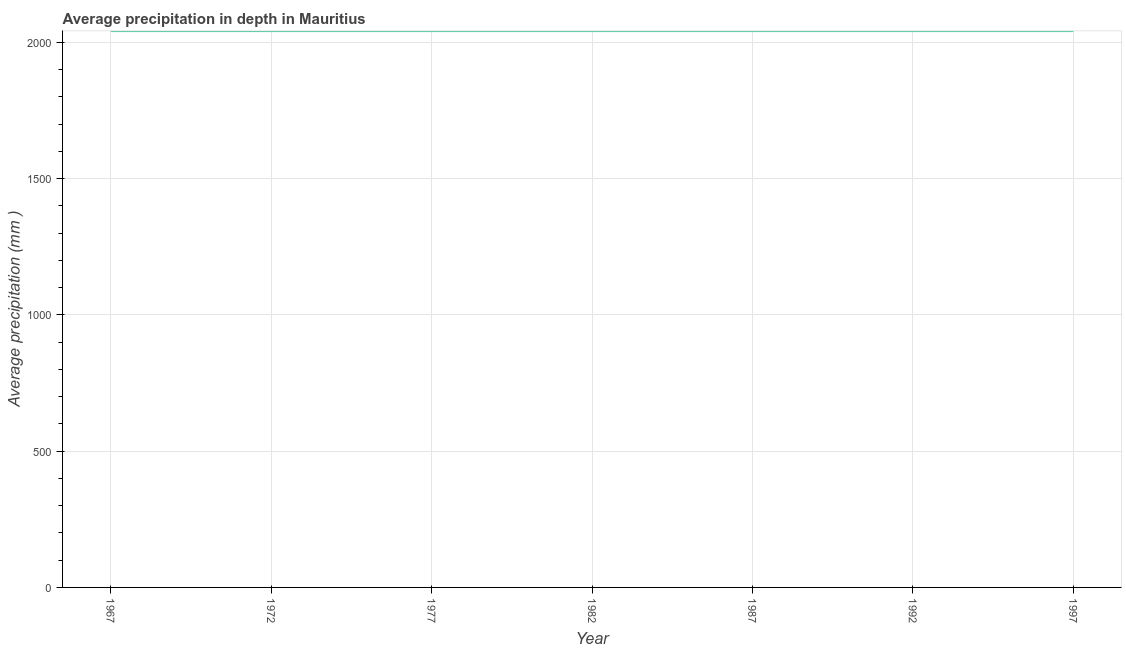What is the average precipitation in depth in 1972?
Keep it short and to the point. 2041. Across all years, what is the maximum average precipitation in depth?
Give a very brief answer. 2041. Across all years, what is the minimum average precipitation in depth?
Offer a terse response. 2041. In which year was the average precipitation in depth maximum?
Your answer should be compact. 1967. In which year was the average precipitation in depth minimum?
Give a very brief answer. 1967. What is the sum of the average precipitation in depth?
Offer a very short reply. 1.43e+04. What is the difference between the average precipitation in depth in 1977 and 1982?
Your answer should be compact. 0. What is the average average precipitation in depth per year?
Ensure brevity in your answer.  2041. What is the median average precipitation in depth?
Offer a very short reply. 2041. Do a majority of the years between 1972 and 1992 (inclusive) have average precipitation in depth greater than 700 mm?
Your answer should be very brief. Yes. Is the sum of the average precipitation in depth in 1967 and 1997 greater than the maximum average precipitation in depth across all years?
Your answer should be very brief. Yes. What is the difference between the highest and the lowest average precipitation in depth?
Provide a succinct answer. 0. Does the average precipitation in depth monotonically increase over the years?
Offer a terse response. No. How many lines are there?
Your response must be concise. 1. How many years are there in the graph?
Make the answer very short. 7. What is the difference between two consecutive major ticks on the Y-axis?
Your answer should be compact. 500. Are the values on the major ticks of Y-axis written in scientific E-notation?
Your answer should be very brief. No. What is the title of the graph?
Give a very brief answer. Average precipitation in depth in Mauritius. What is the label or title of the Y-axis?
Your response must be concise. Average precipitation (mm ). What is the Average precipitation (mm ) in 1967?
Offer a very short reply. 2041. What is the Average precipitation (mm ) of 1972?
Make the answer very short. 2041. What is the Average precipitation (mm ) of 1977?
Provide a succinct answer. 2041. What is the Average precipitation (mm ) of 1982?
Make the answer very short. 2041. What is the Average precipitation (mm ) of 1987?
Make the answer very short. 2041. What is the Average precipitation (mm ) of 1992?
Offer a very short reply. 2041. What is the Average precipitation (mm ) of 1997?
Make the answer very short. 2041. What is the difference between the Average precipitation (mm ) in 1967 and 1977?
Ensure brevity in your answer.  0. What is the difference between the Average precipitation (mm ) in 1967 and 1987?
Give a very brief answer. 0. What is the difference between the Average precipitation (mm ) in 1967 and 1992?
Your response must be concise. 0. What is the difference between the Average precipitation (mm ) in 1972 and 1987?
Offer a terse response. 0. What is the difference between the Average precipitation (mm ) in 1972 and 1997?
Your response must be concise. 0. What is the difference between the Average precipitation (mm ) in 1977 and 1982?
Your answer should be very brief. 0. What is the difference between the Average precipitation (mm ) in 1977 and 1992?
Offer a very short reply. 0. What is the difference between the Average precipitation (mm ) in 1982 and 1992?
Keep it short and to the point. 0. What is the difference between the Average precipitation (mm ) in 1987 and 1992?
Make the answer very short. 0. What is the difference between the Average precipitation (mm ) in 1987 and 1997?
Provide a succinct answer. 0. What is the ratio of the Average precipitation (mm ) in 1967 to that in 1972?
Your answer should be very brief. 1. What is the ratio of the Average precipitation (mm ) in 1967 to that in 1982?
Give a very brief answer. 1. What is the ratio of the Average precipitation (mm ) in 1967 to that in 1987?
Offer a very short reply. 1. What is the ratio of the Average precipitation (mm ) in 1972 to that in 1977?
Your answer should be very brief. 1. What is the ratio of the Average precipitation (mm ) in 1972 to that in 1982?
Your answer should be very brief. 1. What is the ratio of the Average precipitation (mm ) in 1972 to that in 1992?
Provide a succinct answer. 1. What is the ratio of the Average precipitation (mm ) in 1977 to that in 1982?
Offer a terse response. 1. What is the ratio of the Average precipitation (mm ) in 1982 to that in 1987?
Offer a terse response. 1. What is the ratio of the Average precipitation (mm ) in 1982 to that in 1992?
Offer a very short reply. 1. What is the ratio of the Average precipitation (mm ) in 1987 to that in 1992?
Offer a terse response. 1. What is the ratio of the Average precipitation (mm ) in 1987 to that in 1997?
Ensure brevity in your answer.  1. What is the ratio of the Average precipitation (mm ) in 1992 to that in 1997?
Your answer should be compact. 1. 